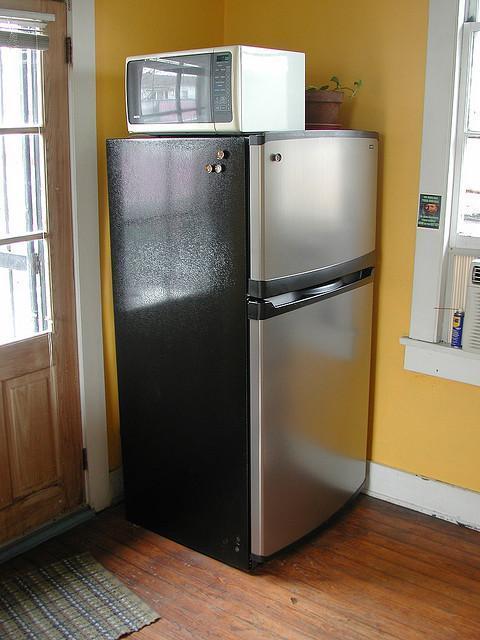How many windows shown?
Give a very brief answer. 2. How many people have cameras up to their faces?
Give a very brief answer. 0. 